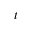<formula> <loc_0><loc_0><loc_500><loc_500>t</formula> 